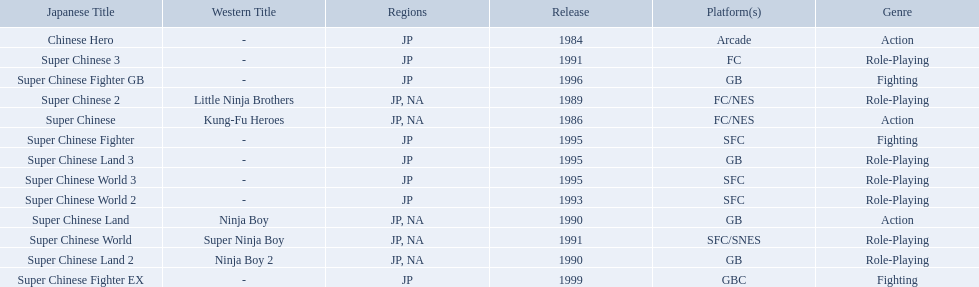Super ninja world was released in what countries? JP, NA. What was the original name for this title? Super Chinese World. 